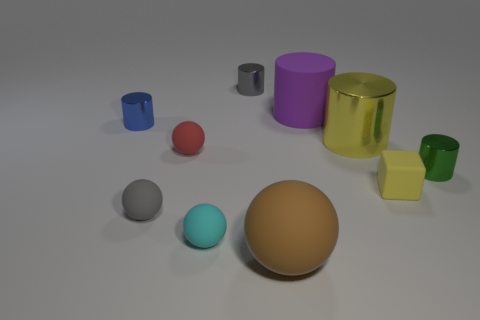Subtract all green cylinders. How many cylinders are left? 4 Subtract all yellow cylinders. How many cylinders are left? 4 Subtract all green cylinders. Subtract all green cubes. How many cylinders are left? 4 Subtract all blocks. How many objects are left? 9 Subtract all big yellow shiny balls. Subtract all large yellow metallic cylinders. How many objects are left? 9 Add 8 small red matte balls. How many small red matte balls are left? 9 Add 7 small cyan things. How many small cyan things exist? 8 Subtract 1 yellow blocks. How many objects are left? 9 